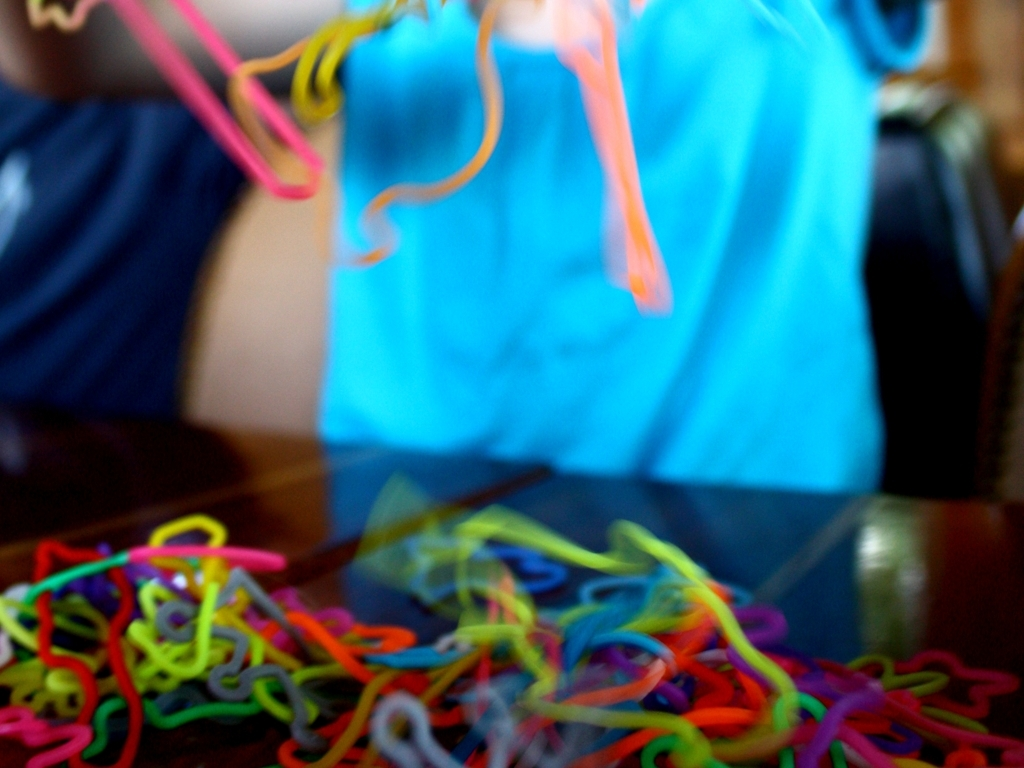Is the image sharp?
 No 